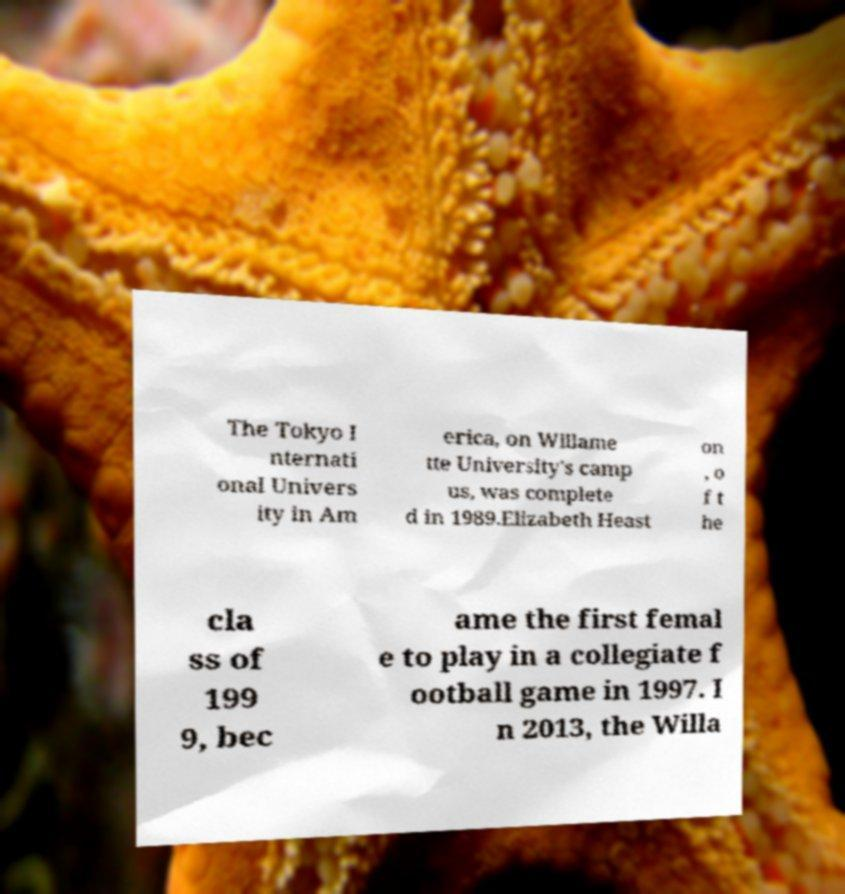What messages or text are displayed in this image? I need them in a readable, typed format. The Tokyo I nternati onal Univers ity in Am erica, on Willame tte University's camp us, was complete d in 1989.Elizabeth Heast on , o f t he cla ss of 199 9, bec ame the first femal e to play in a collegiate f ootball game in 1997. I n 2013, the Willa 